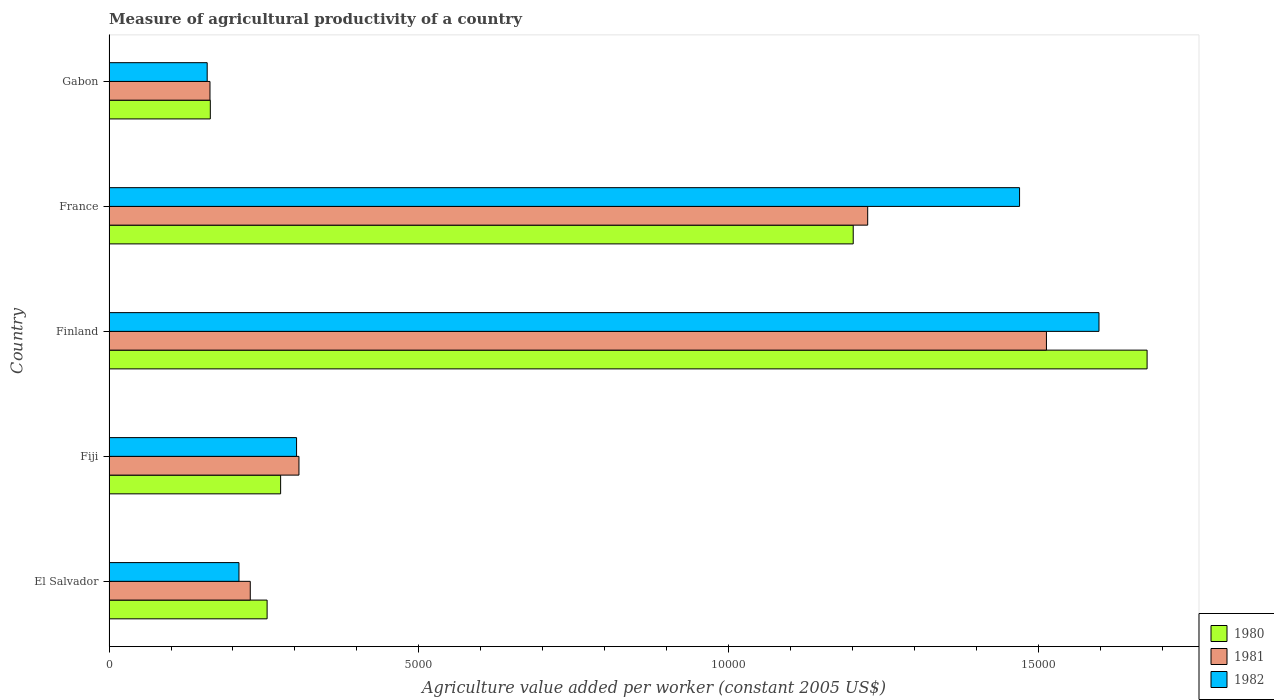Are the number of bars per tick equal to the number of legend labels?
Provide a short and direct response. Yes. Are the number of bars on each tick of the Y-axis equal?
Give a very brief answer. Yes. How many bars are there on the 4th tick from the bottom?
Provide a succinct answer. 3. What is the label of the 1st group of bars from the top?
Make the answer very short. Gabon. In how many cases, is the number of bars for a given country not equal to the number of legend labels?
Your response must be concise. 0. What is the measure of agricultural productivity in 1981 in Finland?
Provide a short and direct response. 1.51e+04. Across all countries, what is the maximum measure of agricultural productivity in 1980?
Your answer should be very brief. 1.67e+04. Across all countries, what is the minimum measure of agricultural productivity in 1980?
Provide a short and direct response. 1634.34. In which country was the measure of agricultural productivity in 1980 maximum?
Offer a terse response. Finland. In which country was the measure of agricultural productivity in 1982 minimum?
Ensure brevity in your answer.  Gabon. What is the total measure of agricultural productivity in 1980 in the graph?
Provide a succinct answer. 3.57e+04. What is the difference between the measure of agricultural productivity in 1982 in Finland and that in France?
Keep it short and to the point. 1281.43. What is the difference between the measure of agricultural productivity in 1981 in El Salvador and the measure of agricultural productivity in 1980 in Finland?
Offer a very short reply. -1.45e+04. What is the average measure of agricultural productivity in 1982 per country?
Offer a terse response. 7474.16. What is the difference between the measure of agricultural productivity in 1982 and measure of agricultural productivity in 1980 in El Salvador?
Offer a very short reply. -454.18. What is the ratio of the measure of agricultural productivity in 1982 in Fiji to that in Gabon?
Your answer should be compact. 1.91. Is the measure of agricultural productivity in 1982 in Fiji less than that in Gabon?
Give a very brief answer. No. What is the difference between the highest and the second highest measure of agricultural productivity in 1982?
Your response must be concise. 1281.43. What is the difference between the highest and the lowest measure of agricultural productivity in 1981?
Provide a short and direct response. 1.35e+04. Is the sum of the measure of agricultural productivity in 1981 in Finland and France greater than the maximum measure of agricultural productivity in 1980 across all countries?
Provide a succinct answer. Yes. What does the 1st bar from the top in Gabon represents?
Provide a succinct answer. 1982. Is it the case that in every country, the sum of the measure of agricultural productivity in 1982 and measure of agricultural productivity in 1981 is greater than the measure of agricultural productivity in 1980?
Your answer should be compact. Yes. How many countries are there in the graph?
Provide a short and direct response. 5. Are the values on the major ticks of X-axis written in scientific E-notation?
Your answer should be very brief. No. Does the graph contain any zero values?
Provide a short and direct response. No. Does the graph contain grids?
Ensure brevity in your answer.  No. How many legend labels are there?
Provide a succinct answer. 3. What is the title of the graph?
Your answer should be compact. Measure of agricultural productivity of a country. What is the label or title of the X-axis?
Give a very brief answer. Agriculture value added per worker (constant 2005 US$). What is the label or title of the Y-axis?
Your answer should be very brief. Country. What is the Agriculture value added per worker (constant 2005 US$) of 1980 in El Salvador?
Provide a short and direct response. 2550.82. What is the Agriculture value added per worker (constant 2005 US$) of 1981 in El Salvador?
Give a very brief answer. 2279.12. What is the Agriculture value added per worker (constant 2005 US$) of 1982 in El Salvador?
Provide a succinct answer. 2096.65. What is the Agriculture value added per worker (constant 2005 US$) of 1980 in Fiji?
Offer a very short reply. 2768.91. What is the Agriculture value added per worker (constant 2005 US$) in 1981 in Fiji?
Ensure brevity in your answer.  3064.53. What is the Agriculture value added per worker (constant 2005 US$) in 1982 in Fiji?
Offer a terse response. 3026.09. What is the Agriculture value added per worker (constant 2005 US$) in 1980 in Finland?
Your response must be concise. 1.67e+04. What is the Agriculture value added per worker (constant 2005 US$) of 1981 in Finland?
Provide a succinct answer. 1.51e+04. What is the Agriculture value added per worker (constant 2005 US$) in 1982 in Finland?
Provide a short and direct response. 1.60e+04. What is the Agriculture value added per worker (constant 2005 US$) of 1980 in France?
Provide a succinct answer. 1.20e+04. What is the Agriculture value added per worker (constant 2005 US$) of 1981 in France?
Offer a very short reply. 1.22e+04. What is the Agriculture value added per worker (constant 2005 US$) in 1982 in France?
Ensure brevity in your answer.  1.47e+04. What is the Agriculture value added per worker (constant 2005 US$) of 1980 in Gabon?
Provide a short and direct response. 1634.34. What is the Agriculture value added per worker (constant 2005 US$) of 1981 in Gabon?
Your answer should be very brief. 1629.22. What is the Agriculture value added per worker (constant 2005 US$) of 1982 in Gabon?
Keep it short and to the point. 1584.05. Across all countries, what is the maximum Agriculture value added per worker (constant 2005 US$) of 1980?
Make the answer very short. 1.67e+04. Across all countries, what is the maximum Agriculture value added per worker (constant 2005 US$) of 1981?
Your response must be concise. 1.51e+04. Across all countries, what is the maximum Agriculture value added per worker (constant 2005 US$) of 1982?
Your answer should be compact. 1.60e+04. Across all countries, what is the minimum Agriculture value added per worker (constant 2005 US$) of 1980?
Provide a short and direct response. 1634.34. Across all countries, what is the minimum Agriculture value added per worker (constant 2005 US$) in 1981?
Make the answer very short. 1629.22. Across all countries, what is the minimum Agriculture value added per worker (constant 2005 US$) in 1982?
Offer a terse response. 1584.05. What is the total Agriculture value added per worker (constant 2005 US$) of 1980 in the graph?
Offer a terse response. 3.57e+04. What is the total Agriculture value added per worker (constant 2005 US$) in 1981 in the graph?
Ensure brevity in your answer.  3.43e+04. What is the total Agriculture value added per worker (constant 2005 US$) of 1982 in the graph?
Offer a very short reply. 3.74e+04. What is the difference between the Agriculture value added per worker (constant 2005 US$) of 1980 in El Salvador and that in Fiji?
Your response must be concise. -218.09. What is the difference between the Agriculture value added per worker (constant 2005 US$) of 1981 in El Salvador and that in Fiji?
Keep it short and to the point. -785.41. What is the difference between the Agriculture value added per worker (constant 2005 US$) in 1982 in El Salvador and that in Fiji?
Your answer should be compact. -929.44. What is the difference between the Agriculture value added per worker (constant 2005 US$) of 1980 in El Salvador and that in Finland?
Provide a succinct answer. -1.42e+04. What is the difference between the Agriculture value added per worker (constant 2005 US$) of 1981 in El Salvador and that in Finland?
Offer a terse response. -1.28e+04. What is the difference between the Agriculture value added per worker (constant 2005 US$) of 1982 in El Salvador and that in Finland?
Ensure brevity in your answer.  -1.39e+04. What is the difference between the Agriculture value added per worker (constant 2005 US$) in 1980 in El Salvador and that in France?
Make the answer very short. -9456.7. What is the difference between the Agriculture value added per worker (constant 2005 US$) of 1981 in El Salvador and that in France?
Your answer should be compact. -9961.89. What is the difference between the Agriculture value added per worker (constant 2005 US$) of 1982 in El Salvador and that in France?
Ensure brevity in your answer.  -1.26e+04. What is the difference between the Agriculture value added per worker (constant 2005 US$) of 1980 in El Salvador and that in Gabon?
Offer a terse response. 916.48. What is the difference between the Agriculture value added per worker (constant 2005 US$) in 1981 in El Salvador and that in Gabon?
Offer a very short reply. 649.9. What is the difference between the Agriculture value added per worker (constant 2005 US$) in 1982 in El Salvador and that in Gabon?
Give a very brief answer. 512.6. What is the difference between the Agriculture value added per worker (constant 2005 US$) in 1980 in Fiji and that in Finland?
Offer a terse response. -1.40e+04. What is the difference between the Agriculture value added per worker (constant 2005 US$) of 1981 in Fiji and that in Finland?
Your answer should be very brief. -1.21e+04. What is the difference between the Agriculture value added per worker (constant 2005 US$) in 1982 in Fiji and that in Finland?
Your response must be concise. -1.29e+04. What is the difference between the Agriculture value added per worker (constant 2005 US$) in 1980 in Fiji and that in France?
Give a very brief answer. -9238.61. What is the difference between the Agriculture value added per worker (constant 2005 US$) of 1981 in Fiji and that in France?
Your answer should be compact. -9176.48. What is the difference between the Agriculture value added per worker (constant 2005 US$) in 1982 in Fiji and that in France?
Give a very brief answer. -1.17e+04. What is the difference between the Agriculture value added per worker (constant 2005 US$) of 1980 in Fiji and that in Gabon?
Ensure brevity in your answer.  1134.57. What is the difference between the Agriculture value added per worker (constant 2005 US$) in 1981 in Fiji and that in Gabon?
Ensure brevity in your answer.  1435.3. What is the difference between the Agriculture value added per worker (constant 2005 US$) in 1982 in Fiji and that in Gabon?
Give a very brief answer. 1442.04. What is the difference between the Agriculture value added per worker (constant 2005 US$) in 1980 in Finland and that in France?
Make the answer very short. 4741.4. What is the difference between the Agriculture value added per worker (constant 2005 US$) of 1981 in Finland and that in France?
Offer a very short reply. 2884.02. What is the difference between the Agriculture value added per worker (constant 2005 US$) in 1982 in Finland and that in France?
Your response must be concise. 1281.43. What is the difference between the Agriculture value added per worker (constant 2005 US$) in 1980 in Finland and that in Gabon?
Your response must be concise. 1.51e+04. What is the difference between the Agriculture value added per worker (constant 2005 US$) in 1981 in Finland and that in Gabon?
Keep it short and to the point. 1.35e+04. What is the difference between the Agriculture value added per worker (constant 2005 US$) of 1982 in Finland and that in Gabon?
Your answer should be very brief. 1.44e+04. What is the difference between the Agriculture value added per worker (constant 2005 US$) in 1980 in France and that in Gabon?
Give a very brief answer. 1.04e+04. What is the difference between the Agriculture value added per worker (constant 2005 US$) of 1981 in France and that in Gabon?
Your answer should be compact. 1.06e+04. What is the difference between the Agriculture value added per worker (constant 2005 US$) of 1982 in France and that in Gabon?
Offer a terse response. 1.31e+04. What is the difference between the Agriculture value added per worker (constant 2005 US$) in 1980 in El Salvador and the Agriculture value added per worker (constant 2005 US$) in 1981 in Fiji?
Your answer should be very brief. -513.7. What is the difference between the Agriculture value added per worker (constant 2005 US$) of 1980 in El Salvador and the Agriculture value added per worker (constant 2005 US$) of 1982 in Fiji?
Give a very brief answer. -475.27. What is the difference between the Agriculture value added per worker (constant 2005 US$) of 1981 in El Salvador and the Agriculture value added per worker (constant 2005 US$) of 1982 in Fiji?
Your answer should be very brief. -746.97. What is the difference between the Agriculture value added per worker (constant 2005 US$) in 1980 in El Salvador and the Agriculture value added per worker (constant 2005 US$) in 1981 in Finland?
Your response must be concise. -1.26e+04. What is the difference between the Agriculture value added per worker (constant 2005 US$) in 1980 in El Salvador and the Agriculture value added per worker (constant 2005 US$) in 1982 in Finland?
Offer a very short reply. -1.34e+04. What is the difference between the Agriculture value added per worker (constant 2005 US$) in 1981 in El Salvador and the Agriculture value added per worker (constant 2005 US$) in 1982 in Finland?
Your answer should be very brief. -1.37e+04. What is the difference between the Agriculture value added per worker (constant 2005 US$) of 1980 in El Salvador and the Agriculture value added per worker (constant 2005 US$) of 1981 in France?
Keep it short and to the point. -9690.18. What is the difference between the Agriculture value added per worker (constant 2005 US$) in 1980 in El Salvador and the Agriculture value added per worker (constant 2005 US$) in 1982 in France?
Make the answer very short. -1.21e+04. What is the difference between the Agriculture value added per worker (constant 2005 US$) in 1981 in El Salvador and the Agriculture value added per worker (constant 2005 US$) in 1982 in France?
Your answer should be compact. -1.24e+04. What is the difference between the Agriculture value added per worker (constant 2005 US$) of 1980 in El Salvador and the Agriculture value added per worker (constant 2005 US$) of 1981 in Gabon?
Provide a succinct answer. 921.6. What is the difference between the Agriculture value added per worker (constant 2005 US$) of 1980 in El Salvador and the Agriculture value added per worker (constant 2005 US$) of 1982 in Gabon?
Your response must be concise. 966.77. What is the difference between the Agriculture value added per worker (constant 2005 US$) of 1981 in El Salvador and the Agriculture value added per worker (constant 2005 US$) of 1982 in Gabon?
Make the answer very short. 695.07. What is the difference between the Agriculture value added per worker (constant 2005 US$) in 1980 in Fiji and the Agriculture value added per worker (constant 2005 US$) in 1981 in Finland?
Keep it short and to the point. -1.24e+04. What is the difference between the Agriculture value added per worker (constant 2005 US$) of 1980 in Fiji and the Agriculture value added per worker (constant 2005 US$) of 1982 in Finland?
Keep it short and to the point. -1.32e+04. What is the difference between the Agriculture value added per worker (constant 2005 US$) in 1981 in Fiji and the Agriculture value added per worker (constant 2005 US$) in 1982 in Finland?
Your answer should be compact. -1.29e+04. What is the difference between the Agriculture value added per worker (constant 2005 US$) in 1980 in Fiji and the Agriculture value added per worker (constant 2005 US$) in 1981 in France?
Your response must be concise. -9472.09. What is the difference between the Agriculture value added per worker (constant 2005 US$) in 1980 in Fiji and the Agriculture value added per worker (constant 2005 US$) in 1982 in France?
Provide a short and direct response. -1.19e+04. What is the difference between the Agriculture value added per worker (constant 2005 US$) in 1981 in Fiji and the Agriculture value added per worker (constant 2005 US$) in 1982 in France?
Offer a very short reply. -1.16e+04. What is the difference between the Agriculture value added per worker (constant 2005 US$) of 1980 in Fiji and the Agriculture value added per worker (constant 2005 US$) of 1981 in Gabon?
Your answer should be compact. 1139.69. What is the difference between the Agriculture value added per worker (constant 2005 US$) in 1980 in Fiji and the Agriculture value added per worker (constant 2005 US$) in 1982 in Gabon?
Keep it short and to the point. 1184.86. What is the difference between the Agriculture value added per worker (constant 2005 US$) in 1981 in Fiji and the Agriculture value added per worker (constant 2005 US$) in 1982 in Gabon?
Your answer should be compact. 1480.47. What is the difference between the Agriculture value added per worker (constant 2005 US$) in 1980 in Finland and the Agriculture value added per worker (constant 2005 US$) in 1981 in France?
Provide a succinct answer. 4507.91. What is the difference between the Agriculture value added per worker (constant 2005 US$) in 1980 in Finland and the Agriculture value added per worker (constant 2005 US$) in 1982 in France?
Your answer should be compact. 2057.63. What is the difference between the Agriculture value added per worker (constant 2005 US$) of 1981 in Finland and the Agriculture value added per worker (constant 2005 US$) of 1982 in France?
Make the answer very short. 433.74. What is the difference between the Agriculture value added per worker (constant 2005 US$) in 1980 in Finland and the Agriculture value added per worker (constant 2005 US$) in 1981 in Gabon?
Provide a succinct answer. 1.51e+04. What is the difference between the Agriculture value added per worker (constant 2005 US$) in 1980 in Finland and the Agriculture value added per worker (constant 2005 US$) in 1982 in Gabon?
Give a very brief answer. 1.52e+04. What is the difference between the Agriculture value added per worker (constant 2005 US$) of 1981 in Finland and the Agriculture value added per worker (constant 2005 US$) of 1982 in Gabon?
Give a very brief answer. 1.35e+04. What is the difference between the Agriculture value added per worker (constant 2005 US$) of 1980 in France and the Agriculture value added per worker (constant 2005 US$) of 1981 in Gabon?
Your answer should be very brief. 1.04e+04. What is the difference between the Agriculture value added per worker (constant 2005 US$) of 1980 in France and the Agriculture value added per worker (constant 2005 US$) of 1982 in Gabon?
Give a very brief answer. 1.04e+04. What is the difference between the Agriculture value added per worker (constant 2005 US$) of 1981 in France and the Agriculture value added per worker (constant 2005 US$) of 1982 in Gabon?
Your response must be concise. 1.07e+04. What is the average Agriculture value added per worker (constant 2005 US$) in 1980 per country?
Your answer should be compact. 7142.1. What is the average Agriculture value added per worker (constant 2005 US$) of 1981 per country?
Give a very brief answer. 6867.78. What is the average Agriculture value added per worker (constant 2005 US$) in 1982 per country?
Offer a very short reply. 7474.16. What is the difference between the Agriculture value added per worker (constant 2005 US$) of 1980 and Agriculture value added per worker (constant 2005 US$) of 1981 in El Salvador?
Provide a succinct answer. 271.71. What is the difference between the Agriculture value added per worker (constant 2005 US$) of 1980 and Agriculture value added per worker (constant 2005 US$) of 1982 in El Salvador?
Your answer should be very brief. 454.18. What is the difference between the Agriculture value added per worker (constant 2005 US$) of 1981 and Agriculture value added per worker (constant 2005 US$) of 1982 in El Salvador?
Your answer should be compact. 182.47. What is the difference between the Agriculture value added per worker (constant 2005 US$) in 1980 and Agriculture value added per worker (constant 2005 US$) in 1981 in Fiji?
Provide a succinct answer. -295.61. What is the difference between the Agriculture value added per worker (constant 2005 US$) of 1980 and Agriculture value added per worker (constant 2005 US$) of 1982 in Fiji?
Provide a succinct answer. -257.18. What is the difference between the Agriculture value added per worker (constant 2005 US$) in 1981 and Agriculture value added per worker (constant 2005 US$) in 1982 in Fiji?
Ensure brevity in your answer.  38.43. What is the difference between the Agriculture value added per worker (constant 2005 US$) of 1980 and Agriculture value added per worker (constant 2005 US$) of 1981 in Finland?
Give a very brief answer. 1623.89. What is the difference between the Agriculture value added per worker (constant 2005 US$) in 1980 and Agriculture value added per worker (constant 2005 US$) in 1982 in Finland?
Provide a short and direct response. 776.2. What is the difference between the Agriculture value added per worker (constant 2005 US$) of 1981 and Agriculture value added per worker (constant 2005 US$) of 1982 in Finland?
Provide a short and direct response. -847.68. What is the difference between the Agriculture value added per worker (constant 2005 US$) of 1980 and Agriculture value added per worker (constant 2005 US$) of 1981 in France?
Offer a very short reply. -233.49. What is the difference between the Agriculture value added per worker (constant 2005 US$) in 1980 and Agriculture value added per worker (constant 2005 US$) in 1982 in France?
Provide a succinct answer. -2683.77. What is the difference between the Agriculture value added per worker (constant 2005 US$) in 1981 and Agriculture value added per worker (constant 2005 US$) in 1982 in France?
Give a very brief answer. -2450.28. What is the difference between the Agriculture value added per worker (constant 2005 US$) in 1980 and Agriculture value added per worker (constant 2005 US$) in 1981 in Gabon?
Your response must be concise. 5.12. What is the difference between the Agriculture value added per worker (constant 2005 US$) of 1980 and Agriculture value added per worker (constant 2005 US$) of 1982 in Gabon?
Provide a succinct answer. 50.29. What is the difference between the Agriculture value added per worker (constant 2005 US$) of 1981 and Agriculture value added per worker (constant 2005 US$) of 1982 in Gabon?
Offer a very short reply. 45.17. What is the ratio of the Agriculture value added per worker (constant 2005 US$) of 1980 in El Salvador to that in Fiji?
Provide a succinct answer. 0.92. What is the ratio of the Agriculture value added per worker (constant 2005 US$) of 1981 in El Salvador to that in Fiji?
Ensure brevity in your answer.  0.74. What is the ratio of the Agriculture value added per worker (constant 2005 US$) in 1982 in El Salvador to that in Fiji?
Your answer should be compact. 0.69. What is the ratio of the Agriculture value added per worker (constant 2005 US$) of 1980 in El Salvador to that in Finland?
Your response must be concise. 0.15. What is the ratio of the Agriculture value added per worker (constant 2005 US$) in 1981 in El Salvador to that in Finland?
Ensure brevity in your answer.  0.15. What is the ratio of the Agriculture value added per worker (constant 2005 US$) of 1982 in El Salvador to that in Finland?
Your answer should be compact. 0.13. What is the ratio of the Agriculture value added per worker (constant 2005 US$) in 1980 in El Salvador to that in France?
Give a very brief answer. 0.21. What is the ratio of the Agriculture value added per worker (constant 2005 US$) of 1981 in El Salvador to that in France?
Offer a terse response. 0.19. What is the ratio of the Agriculture value added per worker (constant 2005 US$) of 1982 in El Salvador to that in France?
Give a very brief answer. 0.14. What is the ratio of the Agriculture value added per worker (constant 2005 US$) of 1980 in El Salvador to that in Gabon?
Provide a short and direct response. 1.56. What is the ratio of the Agriculture value added per worker (constant 2005 US$) in 1981 in El Salvador to that in Gabon?
Ensure brevity in your answer.  1.4. What is the ratio of the Agriculture value added per worker (constant 2005 US$) of 1982 in El Salvador to that in Gabon?
Provide a short and direct response. 1.32. What is the ratio of the Agriculture value added per worker (constant 2005 US$) of 1980 in Fiji to that in Finland?
Ensure brevity in your answer.  0.17. What is the ratio of the Agriculture value added per worker (constant 2005 US$) in 1981 in Fiji to that in Finland?
Keep it short and to the point. 0.2. What is the ratio of the Agriculture value added per worker (constant 2005 US$) in 1982 in Fiji to that in Finland?
Offer a very short reply. 0.19. What is the ratio of the Agriculture value added per worker (constant 2005 US$) in 1980 in Fiji to that in France?
Keep it short and to the point. 0.23. What is the ratio of the Agriculture value added per worker (constant 2005 US$) in 1981 in Fiji to that in France?
Give a very brief answer. 0.25. What is the ratio of the Agriculture value added per worker (constant 2005 US$) in 1982 in Fiji to that in France?
Your answer should be very brief. 0.21. What is the ratio of the Agriculture value added per worker (constant 2005 US$) in 1980 in Fiji to that in Gabon?
Your answer should be compact. 1.69. What is the ratio of the Agriculture value added per worker (constant 2005 US$) in 1981 in Fiji to that in Gabon?
Offer a terse response. 1.88. What is the ratio of the Agriculture value added per worker (constant 2005 US$) in 1982 in Fiji to that in Gabon?
Your answer should be compact. 1.91. What is the ratio of the Agriculture value added per worker (constant 2005 US$) of 1980 in Finland to that in France?
Give a very brief answer. 1.39. What is the ratio of the Agriculture value added per worker (constant 2005 US$) of 1981 in Finland to that in France?
Provide a short and direct response. 1.24. What is the ratio of the Agriculture value added per worker (constant 2005 US$) in 1982 in Finland to that in France?
Your answer should be compact. 1.09. What is the ratio of the Agriculture value added per worker (constant 2005 US$) in 1980 in Finland to that in Gabon?
Offer a terse response. 10.25. What is the ratio of the Agriculture value added per worker (constant 2005 US$) in 1981 in Finland to that in Gabon?
Your answer should be very brief. 9.28. What is the ratio of the Agriculture value added per worker (constant 2005 US$) in 1982 in Finland to that in Gabon?
Offer a terse response. 10.08. What is the ratio of the Agriculture value added per worker (constant 2005 US$) in 1980 in France to that in Gabon?
Offer a very short reply. 7.35. What is the ratio of the Agriculture value added per worker (constant 2005 US$) of 1981 in France to that in Gabon?
Your answer should be compact. 7.51. What is the ratio of the Agriculture value added per worker (constant 2005 US$) of 1982 in France to that in Gabon?
Offer a very short reply. 9.27. What is the difference between the highest and the second highest Agriculture value added per worker (constant 2005 US$) of 1980?
Provide a succinct answer. 4741.4. What is the difference between the highest and the second highest Agriculture value added per worker (constant 2005 US$) of 1981?
Your answer should be very brief. 2884.02. What is the difference between the highest and the second highest Agriculture value added per worker (constant 2005 US$) of 1982?
Offer a very short reply. 1281.43. What is the difference between the highest and the lowest Agriculture value added per worker (constant 2005 US$) in 1980?
Offer a very short reply. 1.51e+04. What is the difference between the highest and the lowest Agriculture value added per worker (constant 2005 US$) of 1981?
Your answer should be very brief. 1.35e+04. What is the difference between the highest and the lowest Agriculture value added per worker (constant 2005 US$) of 1982?
Ensure brevity in your answer.  1.44e+04. 